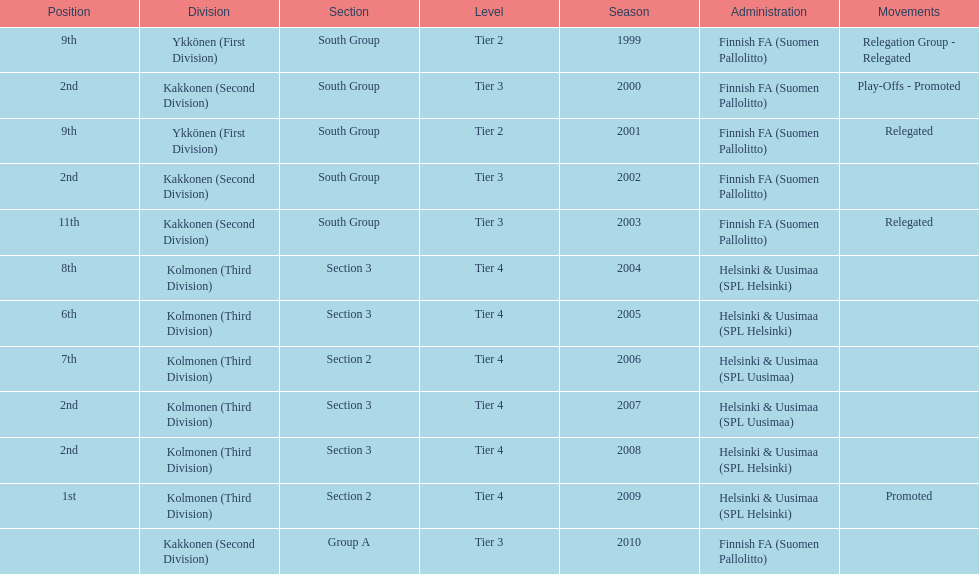How many tiers had more than one relegated movement? 1. 